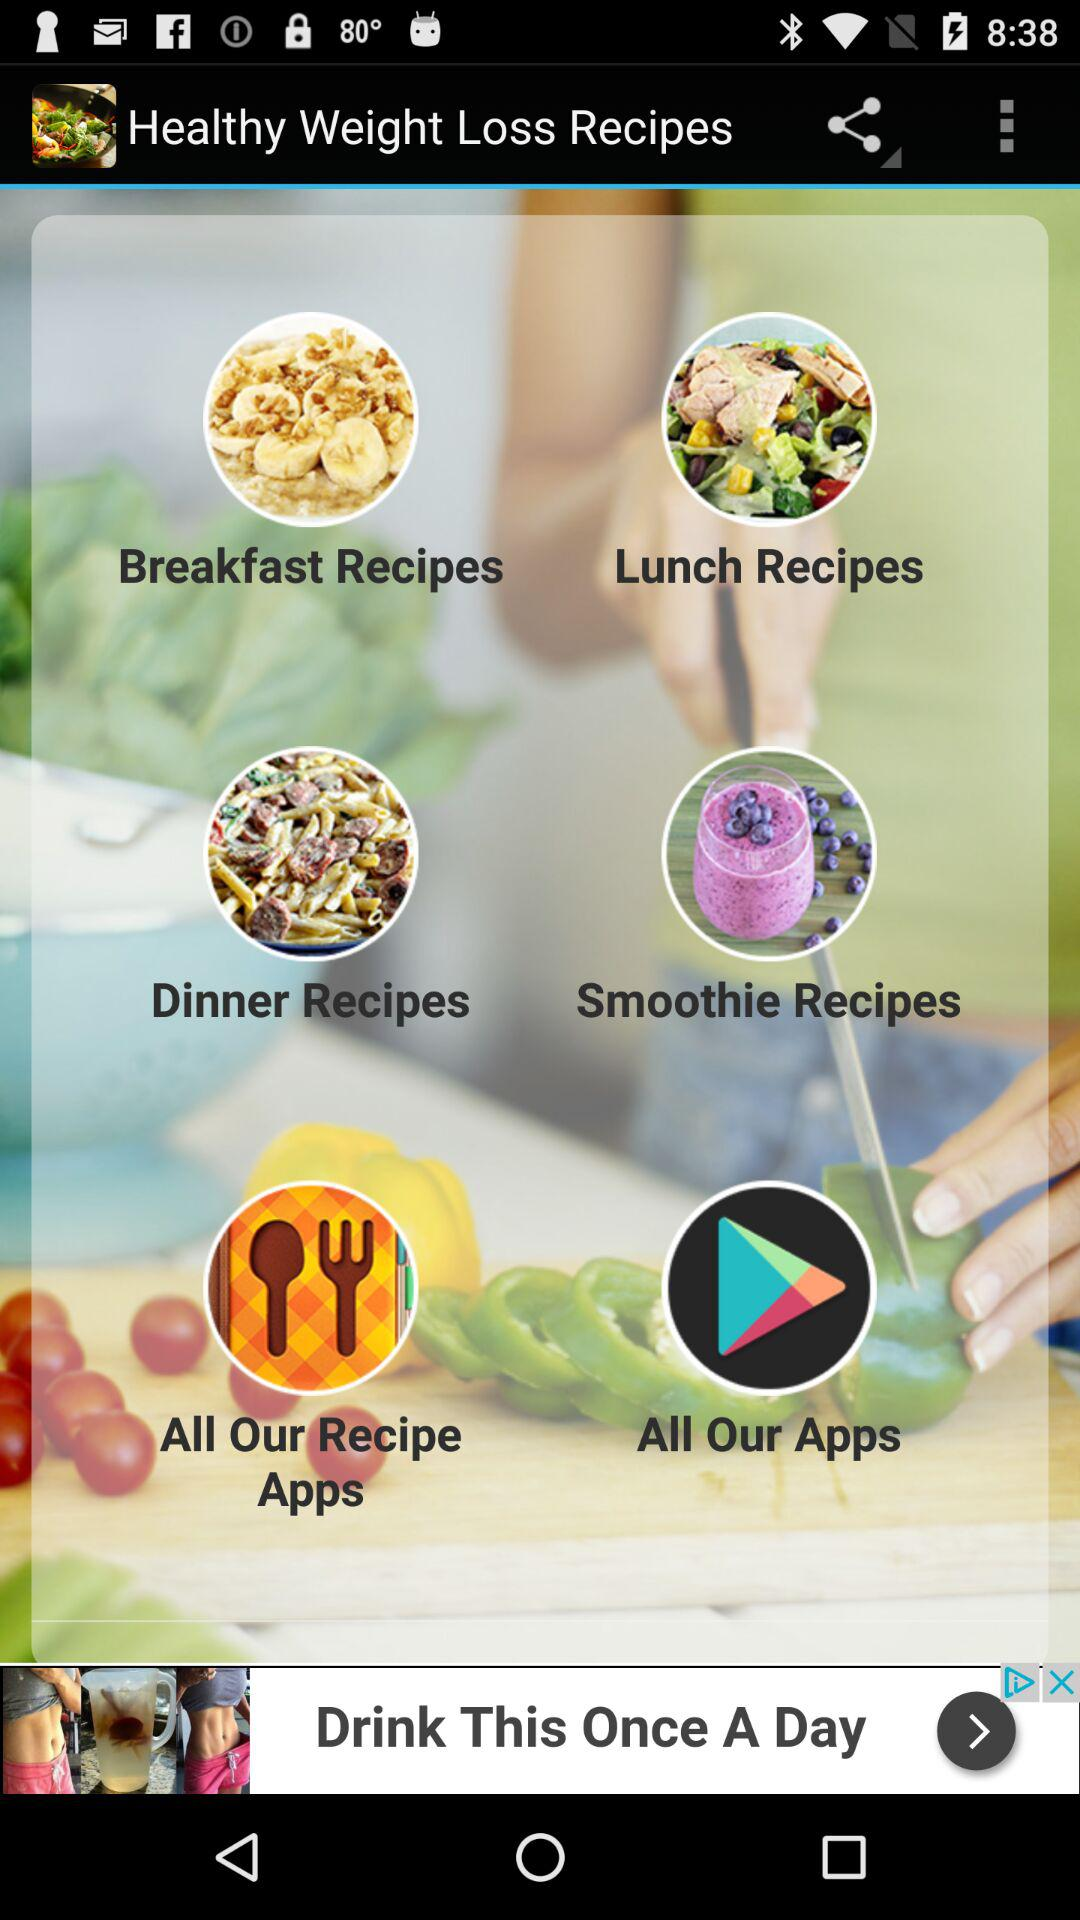What is the application name? The application name is "Healthy Weight Loss Recipes". 